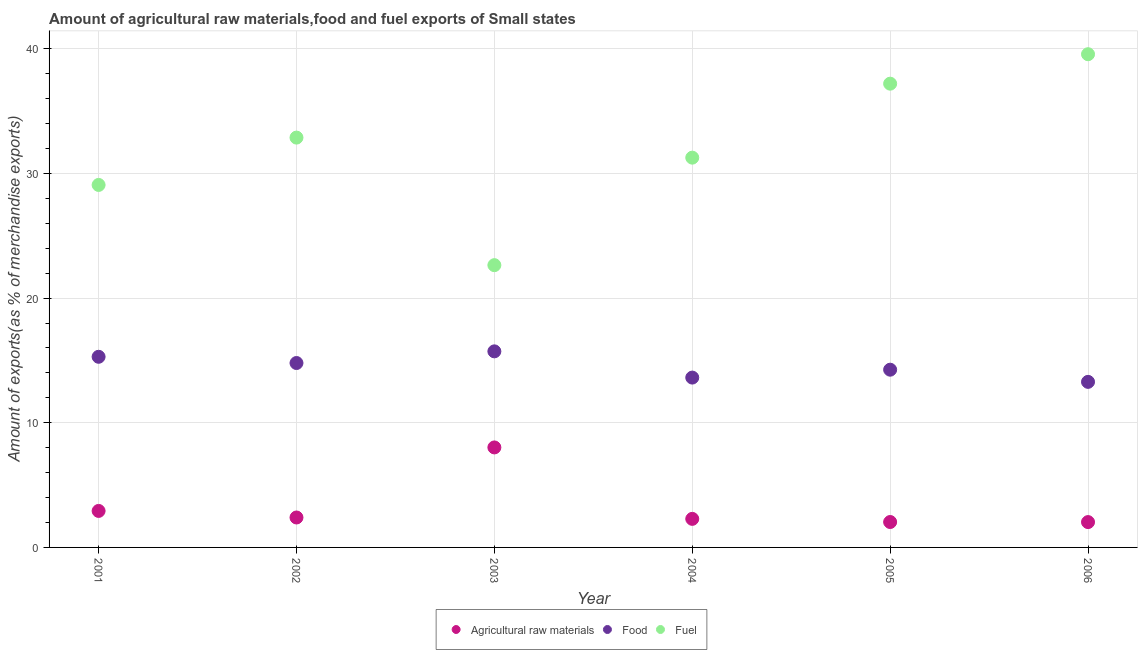Is the number of dotlines equal to the number of legend labels?
Make the answer very short. Yes. What is the percentage of food exports in 2005?
Provide a short and direct response. 14.26. Across all years, what is the maximum percentage of fuel exports?
Provide a short and direct response. 39.56. Across all years, what is the minimum percentage of raw materials exports?
Offer a very short reply. 2.03. In which year was the percentage of food exports maximum?
Ensure brevity in your answer.  2003. In which year was the percentage of raw materials exports minimum?
Provide a short and direct response. 2006. What is the total percentage of food exports in the graph?
Offer a terse response. 86.98. What is the difference between the percentage of food exports in 2003 and that in 2005?
Make the answer very short. 1.47. What is the difference between the percentage of raw materials exports in 2001 and the percentage of fuel exports in 2006?
Your response must be concise. -36.64. What is the average percentage of food exports per year?
Your answer should be very brief. 14.5. In the year 2004, what is the difference between the percentage of food exports and percentage of raw materials exports?
Your answer should be very brief. 11.33. What is the ratio of the percentage of food exports in 2003 to that in 2005?
Offer a very short reply. 1.1. Is the percentage of food exports in 2004 less than that in 2005?
Make the answer very short. Yes. What is the difference between the highest and the second highest percentage of raw materials exports?
Keep it short and to the point. 5.09. What is the difference between the highest and the lowest percentage of fuel exports?
Make the answer very short. 16.92. In how many years, is the percentage of raw materials exports greater than the average percentage of raw materials exports taken over all years?
Provide a short and direct response. 1. Is it the case that in every year, the sum of the percentage of raw materials exports and percentage of food exports is greater than the percentage of fuel exports?
Your answer should be compact. No. Does the percentage of fuel exports monotonically increase over the years?
Offer a terse response. No. Is the percentage of fuel exports strictly greater than the percentage of food exports over the years?
Keep it short and to the point. Yes. Is the percentage of fuel exports strictly less than the percentage of raw materials exports over the years?
Provide a succinct answer. No. What is the difference between two consecutive major ticks on the Y-axis?
Give a very brief answer. 10. Are the values on the major ticks of Y-axis written in scientific E-notation?
Ensure brevity in your answer.  No. How many legend labels are there?
Offer a very short reply. 3. What is the title of the graph?
Your response must be concise. Amount of agricultural raw materials,food and fuel exports of Small states. What is the label or title of the Y-axis?
Offer a very short reply. Amount of exports(as % of merchandise exports). What is the Amount of exports(as % of merchandise exports) of Agricultural raw materials in 2001?
Your answer should be compact. 2.93. What is the Amount of exports(as % of merchandise exports) in Food in 2001?
Offer a very short reply. 15.29. What is the Amount of exports(as % of merchandise exports) of Fuel in 2001?
Make the answer very short. 29.08. What is the Amount of exports(as % of merchandise exports) in Agricultural raw materials in 2002?
Offer a very short reply. 2.4. What is the Amount of exports(as % of merchandise exports) of Food in 2002?
Offer a terse response. 14.79. What is the Amount of exports(as % of merchandise exports) in Fuel in 2002?
Offer a terse response. 32.88. What is the Amount of exports(as % of merchandise exports) in Agricultural raw materials in 2003?
Provide a short and direct response. 8.02. What is the Amount of exports(as % of merchandise exports) of Food in 2003?
Offer a terse response. 15.73. What is the Amount of exports(as % of merchandise exports) of Fuel in 2003?
Ensure brevity in your answer.  22.64. What is the Amount of exports(as % of merchandise exports) of Agricultural raw materials in 2004?
Offer a very short reply. 2.29. What is the Amount of exports(as % of merchandise exports) in Food in 2004?
Your answer should be very brief. 13.62. What is the Amount of exports(as % of merchandise exports) of Fuel in 2004?
Make the answer very short. 31.27. What is the Amount of exports(as % of merchandise exports) in Agricultural raw materials in 2005?
Your answer should be very brief. 2.04. What is the Amount of exports(as % of merchandise exports) of Food in 2005?
Your response must be concise. 14.26. What is the Amount of exports(as % of merchandise exports) in Fuel in 2005?
Ensure brevity in your answer.  37.2. What is the Amount of exports(as % of merchandise exports) of Agricultural raw materials in 2006?
Offer a terse response. 2.03. What is the Amount of exports(as % of merchandise exports) in Food in 2006?
Your response must be concise. 13.28. What is the Amount of exports(as % of merchandise exports) of Fuel in 2006?
Keep it short and to the point. 39.56. Across all years, what is the maximum Amount of exports(as % of merchandise exports) of Agricultural raw materials?
Your answer should be compact. 8.02. Across all years, what is the maximum Amount of exports(as % of merchandise exports) of Food?
Make the answer very short. 15.73. Across all years, what is the maximum Amount of exports(as % of merchandise exports) in Fuel?
Offer a terse response. 39.56. Across all years, what is the minimum Amount of exports(as % of merchandise exports) of Agricultural raw materials?
Your answer should be very brief. 2.03. Across all years, what is the minimum Amount of exports(as % of merchandise exports) of Food?
Ensure brevity in your answer.  13.28. Across all years, what is the minimum Amount of exports(as % of merchandise exports) of Fuel?
Provide a succinct answer. 22.64. What is the total Amount of exports(as % of merchandise exports) of Agricultural raw materials in the graph?
Your answer should be very brief. 19.71. What is the total Amount of exports(as % of merchandise exports) in Food in the graph?
Your answer should be compact. 86.98. What is the total Amount of exports(as % of merchandise exports) of Fuel in the graph?
Provide a short and direct response. 192.63. What is the difference between the Amount of exports(as % of merchandise exports) of Agricultural raw materials in 2001 and that in 2002?
Your answer should be very brief. 0.53. What is the difference between the Amount of exports(as % of merchandise exports) in Food in 2001 and that in 2002?
Offer a very short reply. 0.5. What is the difference between the Amount of exports(as % of merchandise exports) in Fuel in 2001 and that in 2002?
Your answer should be compact. -3.8. What is the difference between the Amount of exports(as % of merchandise exports) in Agricultural raw materials in 2001 and that in 2003?
Offer a very short reply. -5.09. What is the difference between the Amount of exports(as % of merchandise exports) of Food in 2001 and that in 2003?
Make the answer very short. -0.44. What is the difference between the Amount of exports(as % of merchandise exports) in Fuel in 2001 and that in 2003?
Provide a short and direct response. 6.43. What is the difference between the Amount of exports(as % of merchandise exports) in Agricultural raw materials in 2001 and that in 2004?
Keep it short and to the point. 0.64. What is the difference between the Amount of exports(as % of merchandise exports) of Food in 2001 and that in 2004?
Make the answer very short. 1.67. What is the difference between the Amount of exports(as % of merchandise exports) of Fuel in 2001 and that in 2004?
Your response must be concise. -2.19. What is the difference between the Amount of exports(as % of merchandise exports) of Agricultural raw materials in 2001 and that in 2005?
Offer a terse response. 0.89. What is the difference between the Amount of exports(as % of merchandise exports) of Food in 2001 and that in 2005?
Provide a succinct answer. 1.04. What is the difference between the Amount of exports(as % of merchandise exports) in Fuel in 2001 and that in 2005?
Your answer should be compact. -8.12. What is the difference between the Amount of exports(as % of merchandise exports) of Agricultural raw materials in 2001 and that in 2006?
Provide a succinct answer. 0.89. What is the difference between the Amount of exports(as % of merchandise exports) of Food in 2001 and that in 2006?
Provide a short and direct response. 2.01. What is the difference between the Amount of exports(as % of merchandise exports) in Fuel in 2001 and that in 2006?
Offer a terse response. -10.49. What is the difference between the Amount of exports(as % of merchandise exports) of Agricultural raw materials in 2002 and that in 2003?
Ensure brevity in your answer.  -5.62. What is the difference between the Amount of exports(as % of merchandise exports) in Food in 2002 and that in 2003?
Ensure brevity in your answer.  -0.94. What is the difference between the Amount of exports(as % of merchandise exports) in Fuel in 2002 and that in 2003?
Your answer should be very brief. 10.23. What is the difference between the Amount of exports(as % of merchandise exports) in Agricultural raw materials in 2002 and that in 2004?
Keep it short and to the point. 0.11. What is the difference between the Amount of exports(as % of merchandise exports) of Food in 2002 and that in 2004?
Offer a terse response. 1.17. What is the difference between the Amount of exports(as % of merchandise exports) of Fuel in 2002 and that in 2004?
Your answer should be very brief. 1.61. What is the difference between the Amount of exports(as % of merchandise exports) in Agricultural raw materials in 2002 and that in 2005?
Provide a short and direct response. 0.36. What is the difference between the Amount of exports(as % of merchandise exports) in Food in 2002 and that in 2005?
Keep it short and to the point. 0.54. What is the difference between the Amount of exports(as % of merchandise exports) of Fuel in 2002 and that in 2005?
Ensure brevity in your answer.  -4.33. What is the difference between the Amount of exports(as % of merchandise exports) in Agricultural raw materials in 2002 and that in 2006?
Keep it short and to the point. 0.37. What is the difference between the Amount of exports(as % of merchandise exports) in Food in 2002 and that in 2006?
Provide a short and direct response. 1.51. What is the difference between the Amount of exports(as % of merchandise exports) of Fuel in 2002 and that in 2006?
Your response must be concise. -6.69. What is the difference between the Amount of exports(as % of merchandise exports) in Agricultural raw materials in 2003 and that in 2004?
Keep it short and to the point. 5.73. What is the difference between the Amount of exports(as % of merchandise exports) in Food in 2003 and that in 2004?
Keep it short and to the point. 2.1. What is the difference between the Amount of exports(as % of merchandise exports) of Fuel in 2003 and that in 2004?
Offer a very short reply. -8.62. What is the difference between the Amount of exports(as % of merchandise exports) of Agricultural raw materials in 2003 and that in 2005?
Keep it short and to the point. 5.98. What is the difference between the Amount of exports(as % of merchandise exports) of Food in 2003 and that in 2005?
Ensure brevity in your answer.  1.47. What is the difference between the Amount of exports(as % of merchandise exports) of Fuel in 2003 and that in 2005?
Offer a terse response. -14.56. What is the difference between the Amount of exports(as % of merchandise exports) of Agricultural raw materials in 2003 and that in 2006?
Provide a short and direct response. 5.99. What is the difference between the Amount of exports(as % of merchandise exports) in Food in 2003 and that in 2006?
Provide a succinct answer. 2.45. What is the difference between the Amount of exports(as % of merchandise exports) in Fuel in 2003 and that in 2006?
Keep it short and to the point. -16.92. What is the difference between the Amount of exports(as % of merchandise exports) in Agricultural raw materials in 2004 and that in 2005?
Your response must be concise. 0.25. What is the difference between the Amount of exports(as % of merchandise exports) of Food in 2004 and that in 2005?
Make the answer very short. -0.63. What is the difference between the Amount of exports(as % of merchandise exports) of Fuel in 2004 and that in 2005?
Offer a very short reply. -5.93. What is the difference between the Amount of exports(as % of merchandise exports) in Agricultural raw materials in 2004 and that in 2006?
Ensure brevity in your answer.  0.26. What is the difference between the Amount of exports(as % of merchandise exports) of Food in 2004 and that in 2006?
Your response must be concise. 0.34. What is the difference between the Amount of exports(as % of merchandise exports) in Fuel in 2004 and that in 2006?
Your answer should be compact. -8.3. What is the difference between the Amount of exports(as % of merchandise exports) in Agricultural raw materials in 2005 and that in 2006?
Offer a terse response. 0.01. What is the difference between the Amount of exports(as % of merchandise exports) in Food in 2005 and that in 2006?
Offer a terse response. 0.98. What is the difference between the Amount of exports(as % of merchandise exports) in Fuel in 2005 and that in 2006?
Give a very brief answer. -2.36. What is the difference between the Amount of exports(as % of merchandise exports) in Agricultural raw materials in 2001 and the Amount of exports(as % of merchandise exports) in Food in 2002?
Make the answer very short. -11.87. What is the difference between the Amount of exports(as % of merchandise exports) in Agricultural raw materials in 2001 and the Amount of exports(as % of merchandise exports) in Fuel in 2002?
Offer a very short reply. -29.95. What is the difference between the Amount of exports(as % of merchandise exports) of Food in 2001 and the Amount of exports(as % of merchandise exports) of Fuel in 2002?
Make the answer very short. -17.58. What is the difference between the Amount of exports(as % of merchandise exports) of Agricultural raw materials in 2001 and the Amount of exports(as % of merchandise exports) of Food in 2003?
Give a very brief answer. -12.8. What is the difference between the Amount of exports(as % of merchandise exports) of Agricultural raw materials in 2001 and the Amount of exports(as % of merchandise exports) of Fuel in 2003?
Ensure brevity in your answer.  -19.72. What is the difference between the Amount of exports(as % of merchandise exports) of Food in 2001 and the Amount of exports(as % of merchandise exports) of Fuel in 2003?
Provide a short and direct response. -7.35. What is the difference between the Amount of exports(as % of merchandise exports) of Agricultural raw materials in 2001 and the Amount of exports(as % of merchandise exports) of Food in 2004?
Provide a succinct answer. -10.7. What is the difference between the Amount of exports(as % of merchandise exports) in Agricultural raw materials in 2001 and the Amount of exports(as % of merchandise exports) in Fuel in 2004?
Your response must be concise. -28.34. What is the difference between the Amount of exports(as % of merchandise exports) of Food in 2001 and the Amount of exports(as % of merchandise exports) of Fuel in 2004?
Ensure brevity in your answer.  -15.97. What is the difference between the Amount of exports(as % of merchandise exports) of Agricultural raw materials in 2001 and the Amount of exports(as % of merchandise exports) of Food in 2005?
Provide a short and direct response. -11.33. What is the difference between the Amount of exports(as % of merchandise exports) in Agricultural raw materials in 2001 and the Amount of exports(as % of merchandise exports) in Fuel in 2005?
Provide a short and direct response. -34.27. What is the difference between the Amount of exports(as % of merchandise exports) of Food in 2001 and the Amount of exports(as % of merchandise exports) of Fuel in 2005?
Keep it short and to the point. -21.91. What is the difference between the Amount of exports(as % of merchandise exports) in Agricultural raw materials in 2001 and the Amount of exports(as % of merchandise exports) in Food in 2006?
Your answer should be compact. -10.35. What is the difference between the Amount of exports(as % of merchandise exports) in Agricultural raw materials in 2001 and the Amount of exports(as % of merchandise exports) in Fuel in 2006?
Offer a terse response. -36.64. What is the difference between the Amount of exports(as % of merchandise exports) of Food in 2001 and the Amount of exports(as % of merchandise exports) of Fuel in 2006?
Your answer should be compact. -24.27. What is the difference between the Amount of exports(as % of merchandise exports) in Agricultural raw materials in 2002 and the Amount of exports(as % of merchandise exports) in Food in 2003?
Offer a very short reply. -13.33. What is the difference between the Amount of exports(as % of merchandise exports) in Agricultural raw materials in 2002 and the Amount of exports(as % of merchandise exports) in Fuel in 2003?
Provide a short and direct response. -20.24. What is the difference between the Amount of exports(as % of merchandise exports) of Food in 2002 and the Amount of exports(as % of merchandise exports) of Fuel in 2003?
Your answer should be compact. -7.85. What is the difference between the Amount of exports(as % of merchandise exports) in Agricultural raw materials in 2002 and the Amount of exports(as % of merchandise exports) in Food in 2004?
Make the answer very short. -11.22. What is the difference between the Amount of exports(as % of merchandise exports) in Agricultural raw materials in 2002 and the Amount of exports(as % of merchandise exports) in Fuel in 2004?
Your answer should be compact. -28.87. What is the difference between the Amount of exports(as % of merchandise exports) in Food in 2002 and the Amount of exports(as % of merchandise exports) in Fuel in 2004?
Make the answer very short. -16.47. What is the difference between the Amount of exports(as % of merchandise exports) in Agricultural raw materials in 2002 and the Amount of exports(as % of merchandise exports) in Food in 2005?
Offer a terse response. -11.86. What is the difference between the Amount of exports(as % of merchandise exports) in Agricultural raw materials in 2002 and the Amount of exports(as % of merchandise exports) in Fuel in 2005?
Ensure brevity in your answer.  -34.8. What is the difference between the Amount of exports(as % of merchandise exports) of Food in 2002 and the Amount of exports(as % of merchandise exports) of Fuel in 2005?
Offer a very short reply. -22.41. What is the difference between the Amount of exports(as % of merchandise exports) in Agricultural raw materials in 2002 and the Amount of exports(as % of merchandise exports) in Food in 2006?
Your answer should be compact. -10.88. What is the difference between the Amount of exports(as % of merchandise exports) of Agricultural raw materials in 2002 and the Amount of exports(as % of merchandise exports) of Fuel in 2006?
Keep it short and to the point. -37.16. What is the difference between the Amount of exports(as % of merchandise exports) in Food in 2002 and the Amount of exports(as % of merchandise exports) in Fuel in 2006?
Your answer should be very brief. -24.77. What is the difference between the Amount of exports(as % of merchandise exports) of Agricultural raw materials in 2003 and the Amount of exports(as % of merchandise exports) of Food in 2004?
Provide a succinct answer. -5.6. What is the difference between the Amount of exports(as % of merchandise exports) of Agricultural raw materials in 2003 and the Amount of exports(as % of merchandise exports) of Fuel in 2004?
Provide a short and direct response. -23.25. What is the difference between the Amount of exports(as % of merchandise exports) of Food in 2003 and the Amount of exports(as % of merchandise exports) of Fuel in 2004?
Your answer should be compact. -15.54. What is the difference between the Amount of exports(as % of merchandise exports) of Agricultural raw materials in 2003 and the Amount of exports(as % of merchandise exports) of Food in 2005?
Offer a very short reply. -6.24. What is the difference between the Amount of exports(as % of merchandise exports) of Agricultural raw materials in 2003 and the Amount of exports(as % of merchandise exports) of Fuel in 2005?
Offer a terse response. -29.18. What is the difference between the Amount of exports(as % of merchandise exports) of Food in 2003 and the Amount of exports(as % of merchandise exports) of Fuel in 2005?
Ensure brevity in your answer.  -21.47. What is the difference between the Amount of exports(as % of merchandise exports) of Agricultural raw materials in 2003 and the Amount of exports(as % of merchandise exports) of Food in 2006?
Keep it short and to the point. -5.26. What is the difference between the Amount of exports(as % of merchandise exports) of Agricultural raw materials in 2003 and the Amount of exports(as % of merchandise exports) of Fuel in 2006?
Your answer should be very brief. -31.54. What is the difference between the Amount of exports(as % of merchandise exports) in Food in 2003 and the Amount of exports(as % of merchandise exports) in Fuel in 2006?
Make the answer very short. -23.84. What is the difference between the Amount of exports(as % of merchandise exports) in Agricultural raw materials in 2004 and the Amount of exports(as % of merchandise exports) in Food in 2005?
Ensure brevity in your answer.  -11.97. What is the difference between the Amount of exports(as % of merchandise exports) of Agricultural raw materials in 2004 and the Amount of exports(as % of merchandise exports) of Fuel in 2005?
Offer a terse response. -34.91. What is the difference between the Amount of exports(as % of merchandise exports) in Food in 2004 and the Amount of exports(as % of merchandise exports) in Fuel in 2005?
Give a very brief answer. -23.58. What is the difference between the Amount of exports(as % of merchandise exports) of Agricultural raw materials in 2004 and the Amount of exports(as % of merchandise exports) of Food in 2006?
Offer a very short reply. -10.99. What is the difference between the Amount of exports(as % of merchandise exports) in Agricultural raw materials in 2004 and the Amount of exports(as % of merchandise exports) in Fuel in 2006?
Offer a very short reply. -37.27. What is the difference between the Amount of exports(as % of merchandise exports) of Food in 2004 and the Amount of exports(as % of merchandise exports) of Fuel in 2006?
Offer a very short reply. -25.94. What is the difference between the Amount of exports(as % of merchandise exports) of Agricultural raw materials in 2005 and the Amount of exports(as % of merchandise exports) of Food in 2006?
Offer a very short reply. -11.24. What is the difference between the Amount of exports(as % of merchandise exports) in Agricultural raw materials in 2005 and the Amount of exports(as % of merchandise exports) in Fuel in 2006?
Make the answer very short. -37.53. What is the difference between the Amount of exports(as % of merchandise exports) of Food in 2005 and the Amount of exports(as % of merchandise exports) of Fuel in 2006?
Keep it short and to the point. -25.31. What is the average Amount of exports(as % of merchandise exports) in Agricultural raw materials per year?
Make the answer very short. 3.29. What is the average Amount of exports(as % of merchandise exports) of Food per year?
Your answer should be very brief. 14.5. What is the average Amount of exports(as % of merchandise exports) in Fuel per year?
Your answer should be compact. 32.1. In the year 2001, what is the difference between the Amount of exports(as % of merchandise exports) in Agricultural raw materials and Amount of exports(as % of merchandise exports) in Food?
Your answer should be compact. -12.37. In the year 2001, what is the difference between the Amount of exports(as % of merchandise exports) in Agricultural raw materials and Amount of exports(as % of merchandise exports) in Fuel?
Offer a terse response. -26.15. In the year 2001, what is the difference between the Amount of exports(as % of merchandise exports) of Food and Amount of exports(as % of merchandise exports) of Fuel?
Offer a terse response. -13.79. In the year 2002, what is the difference between the Amount of exports(as % of merchandise exports) of Agricultural raw materials and Amount of exports(as % of merchandise exports) of Food?
Offer a very short reply. -12.39. In the year 2002, what is the difference between the Amount of exports(as % of merchandise exports) in Agricultural raw materials and Amount of exports(as % of merchandise exports) in Fuel?
Ensure brevity in your answer.  -30.47. In the year 2002, what is the difference between the Amount of exports(as % of merchandise exports) of Food and Amount of exports(as % of merchandise exports) of Fuel?
Ensure brevity in your answer.  -18.08. In the year 2003, what is the difference between the Amount of exports(as % of merchandise exports) in Agricultural raw materials and Amount of exports(as % of merchandise exports) in Food?
Provide a short and direct response. -7.71. In the year 2003, what is the difference between the Amount of exports(as % of merchandise exports) of Agricultural raw materials and Amount of exports(as % of merchandise exports) of Fuel?
Provide a succinct answer. -14.62. In the year 2003, what is the difference between the Amount of exports(as % of merchandise exports) in Food and Amount of exports(as % of merchandise exports) in Fuel?
Give a very brief answer. -6.91. In the year 2004, what is the difference between the Amount of exports(as % of merchandise exports) of Agricultural raw materials and Amount of exports(as % of merchandise exports) of Food?
Make the answer very short. -11.33. In the year 2004, what is the difference between the Amount of exports(as % of merchandise exports) in Agricultural raw materials and Amount of exports(as % of merchandise exports) in Fuel?
Offer a terse response. -28.98. In the year 2004, what is the difference between the Amount of exports(as % of merchandise exports) in Food and Amount of exports(as % of merchandise exports) in Fuel?
Make the answer very short. -17.64. In the year 2005, what is the difference between the Amount of exports(as % of merchandise exports) of Agricultural raw materials and Amount of exports(as % of merchandise exports) of Food?
Your answer should be very brief. -12.22. In the year 2005, what is the difference between the Amount of exports(as % of merchandise exports) in Agricultural raw materials and Amount of exports(as % of merchandise exports) in Fuel?
Your answer should be very brief. -35.16. In the year 2005, what is the difference between the Amount of exports(as % of merchandise exports) in Food and Amount of exports(as % of merchandise exports) in Fuel?
Provide a short and direct response. -22.94. In the year 2006, what is the difference between the Amount of exports(as % of merchandise exports) of Agricultural raw materials and Amount of exports(as % of merchandise exports) of Food?
Provide a short and direct response. -11.25. In the year 2006, what is the difference between the Amount of exports(as % of merchandise exports) in Agricultural raw materials and Amount of exports(as % of merchandise exports) in Fuel?
Provide a succinct answer. -37.53. In the year 2006, what is the difference between the Amount of exports(as % of merchandise exports) in Food and Amount of exports(as % of merchandise exports) in Fuel?
Ensure brevity in your answer.  -26.28. What is the ratio of the Amount of exports(as % of merchandise exports) of Agricultural raw materials in 2001 to that in 2002?
Offer a terse response. 1.22. What is the ratio of the Amount of exports(as % of merchandise exports) of Food in 2001 to that in 2002?
Make the answer very short. 1.03. What is the ratio of the Amount of exports(as % of merchandise exports) in Fuel in 2001 to that in 2002?
Your answer should be very brief. 0.88. What is the ratio of the Amount of exports(as % of merchandise exports) of Agricultural raw materials in 2001 to that in 2003?
Make the answer very short. 0.36. What is the ratio of the Amount of exports(as % of merchandise exports) of Food in 2001 to that in 2003?
Provide a short and direct response. 0.97. What is the ratio of the Amount of exports(as % of merchandise exports) in Fuel in 2001 to that in 2003?
Your response must be concise. 1.28. What is the ratio of the Amount of exports(as % of merchandise exports) in Agricultural raw materials in 2001 to that in 2004?
Make the answer very short. 1.28. What is the ratio of the Amount of exports(as % of merchandise exports) of Food in 2001 to that in 2004?
Your answer should be very brief. 1.12. What is the ratio of the Amount of exports(as % of merchandise exports) of Agricultural raw materials in 2001 to that in 2005?
Your answer should be compact. 1.44. What is the ratio of the Amount of exports(as % of merchandise exports) of Food in 2001 to that in 2005?
Offer a very short reply. 1.07. What is the ratio of the Amount of exports(as % of merchandise exports) of Fuel in 2001 to that in 2005?
Provide a succinct answer. 0.78. What is the ratio of the Amount of exports(as % of merchandise exports) in Agricultural raw materials in 2001 to that in 2006?
Your response must be concise. 1.44. What is the ratio of the Amount of exports(as % of merchandise exports) of Food in 2001 to that in 2006?
Keep it short and to the point. 1.15. What is the ratio of the Amount of exports(as % of merchandise exports) in Fuel in 2001 to that in 2006?
Ensure brevity in your answer.  0.73. What is the ratio of the Amount of exports(as % of merchandise exports) of Agricultural raw materials in 2002 to that in 2003?
Provide a succinct answer. 0.3. What is the ratio of the Amount of exports(as % of merchandise exports) of Food in 2002 to that in 2003?
Give a very brief answer. 0.94. What is the ratio of the Amount of exports(as % of merchandise exports) of Fuel in 2002 to that in 2003?
Provide a short and direct response. 1.45. What is the ratio of the Amount of exports(as % of merchandise exports) of Agricultural raw materials in 2002 to that in 2004?
Provide a short and direct response. 1.05. What is the ratio of the Amount of exports(as % of merchandise exports) of Food in 2002 to that in 2004?
Offer a terse response. 1.09. What is the ratio of the Amount of exports(as % of merchandise exports) in Fuel in 2002 to that in 2004?
Offer a very short reply. 1.05. What is the ratio of the Amount of exports(as % of merchandise exports) in Agricultural raw materials in 2002 to that in 2005?
Keep it short and to the point. 1.18. What is the ratio of the Amount of exports(as % of merchandise exports) of Food in 2002 to that in 2005?
Offer a terse response. 1.04. What is the ratio of the Amount of exports(as % of merchandise exports) in Fuel in 2002 to that in 2005?
Ensure brevity in your answer.  0.88. What is the ratio of the Amount of exports(as % of merchandise exports) in Agricultural raw materials in 2002 to that in 2006?
Provide a short and direct response. 1.18. What is the ratio of the Amount of exports(as % of merchandise exports) of Food in 2002 to that in 2006?
Provide a short and direct response. 1.11. What is the ratio of the Amount of exports(as % of merchandise exports) in Fuel in 2002 to that in 2006?
Offer a terse response. 0.83. What is the ratio of the Amount of exports(as % of merchandise exports) in Agricultural raw materials in 2003 to that in 2004?
Make the answer very short. 3.5. What is the ratio of the Amount of exports(as % of merchandise exports) in Food in 2003 to that in 2004?
Keep it short and to the point. 1.15. What is the ratio of the Amount of exports(as % of merchandise exports) in Fuel in 2003 to that in 2004?
Keep it short and to the point. 0.72. What is the ratio of the Amount of exports(as % of merchandise exports) of Agricultural raw materials in 2003 to that in 2005?
Your answer should be very brief. 3.93. What is the ratio of the Amount of exports(as % of merchandise exports) of Food in 2003 to that in 2005?
Offer a terse response. 1.1. What is the ratio of the Amount of exports(as % of merchandise exports) of Fuel in 2003 to that in 2005?
Your answer should be compact. 0.61. What is the ratio of the Amount of exports(as % of merchandise exports) in Agricultural raw materials in 2003 to that in 2006?
Offer a very short reply. 3.95. What is the ratio of the Amount of exports(as % of merchandise exports) in Food in 2003 to that in 2006?
Keep it short and to the point. 1.18. What is the ratio of the Amount of exports(as % of merchandise exports) of Fuel in 2003 to that in 2006?
Provide a short and direct response. 0.57. What is the ratio of the Amount of exports(as % of merchandise exports) in Agricultural raw materials in 2004 to that in 2005?
Your response must be concise. 1.12. What is the ratio of the Amount of exports(as % of merchandise exports) in Food in 2004 to that in 2005?
Your response must be concise. 0.96. What is the ratio of the Amount of exports(as % of merchandise exports) in Fuel in 2004 to that in 2005?
Offer a very short reply. 0.84. What is the ratio of the Amount of exports(as % of merchandise exports) in Agricultural raw materials in 2004 to that in 2006?
Give a very brief answer. 1.13. What is the ratio of the Amount of exports(as % of merchandise exports) of Food in 2004 to that in 2006?
Make the answer very short. 1.03. What is the ratio of the Amount of exports(as % of merchandise exports) of Fuel in 2004 to that in 2006?
Keep it short and to the point. 0.79. What is the ratio of the Amount of exports(as % of merchandise exports) in Agricultural raw materials in 2005 to that in 2006?
Provide a succinct answer. 1. What is the ratio of the Amount of exports(as % of merchandise exports) of Food in 2005 to that in 2006?
Give a very brief answer. 1.07. What is the ratio of the Amount of exports(as % of merchandise exports) of Fuel in 2005 to that in 2006?
Ensure brevity in your answer.  0.94. What is the difference between the highest and the second highest Amount of exports(as % of merchandise exports) of Agricultural raw materials?
Your answer should be very brief. 5.09. What is the difference between the highest and the second highest Amount of exports(as % of merchandise exports) of Food?
Provide a succinct answer. 0.44. What is the difference between the highest and the second highest Amount of exports(as % of merchandise exports) of Fuel?
Keep it short and to the point. 2.36. What is the difference between the highest and the lowest Amount of exports(as % of merchandise exports) in Agricultural raw materials?
Provide a succinct answer. 5.99. What is the difference between the highest and the lowest Amount of exports(as % of merchandise exports) of Food?
Provide a succinct answer. 2.45. What is the difference between the highest and the lowest Amount of exports(as % of merchandise exports) of Fuel?
Ensure brevity in your answer.  16.92. 